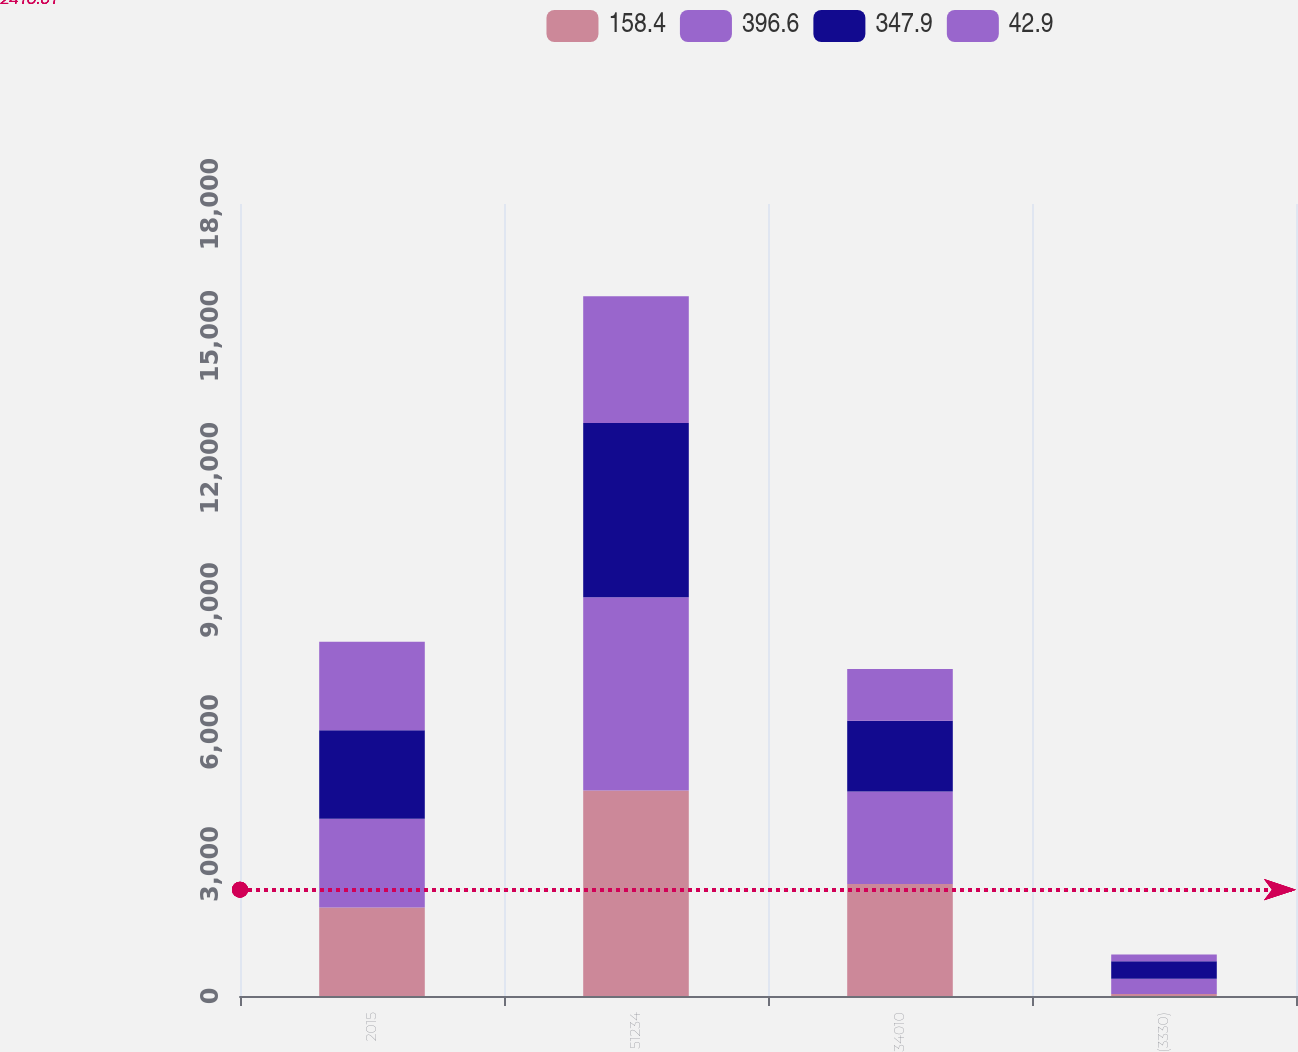Convert chart. <chart><loc_0><loc_0><loc_500><loc_500><stacked_bar_chart><ecel><fcel>2015<fcel>51234<fcel>34010<fcel>(3330)<nl><fcel>158.4<fcel>2014<fcel>4669<fcel>2547.3<fcel>42.9<nl><fcel>396.6<fcel>2013<fcel>4395.1<fcel>2101.8<fcel>347.9<nl><fcel>347.9<fcel>2012<fcel>3960.9<fcel>1607.4<fcel>396.6<nl><fcel>42.9<fcel>2011<fcel>2876.1<fcel>1172.5<fcel>158.4<nl></chart> 